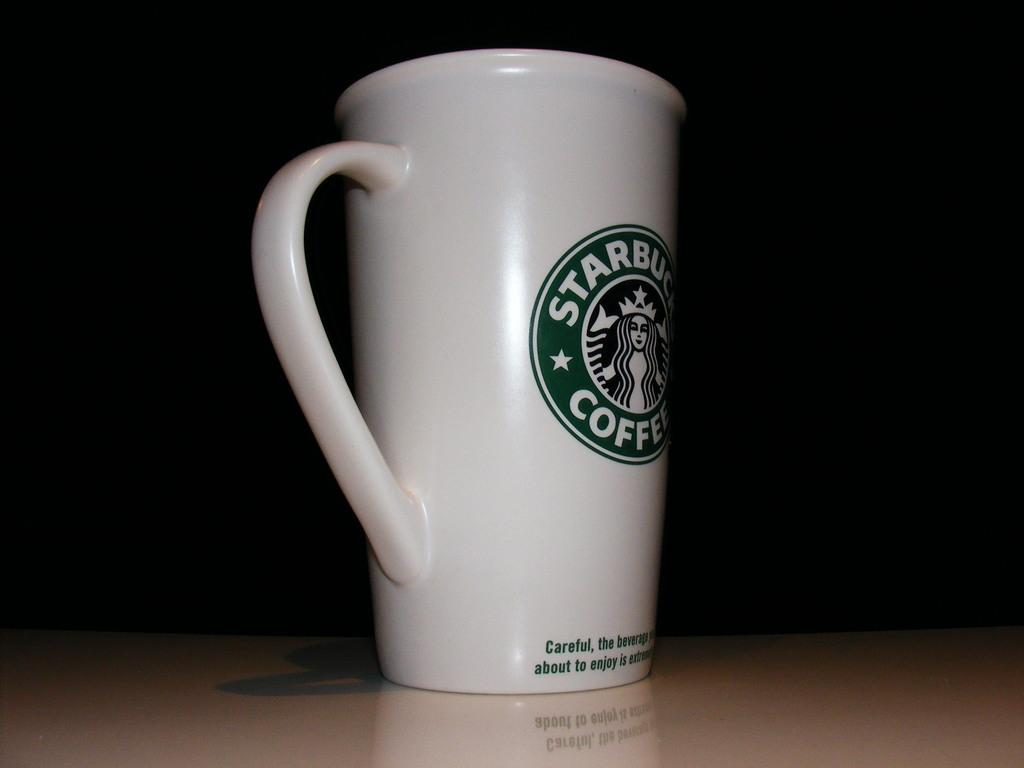<image>
Relay a brief, clear account of the picture shown. Starbucks Coffee is the brand name and logo shown on this coffee cup. 